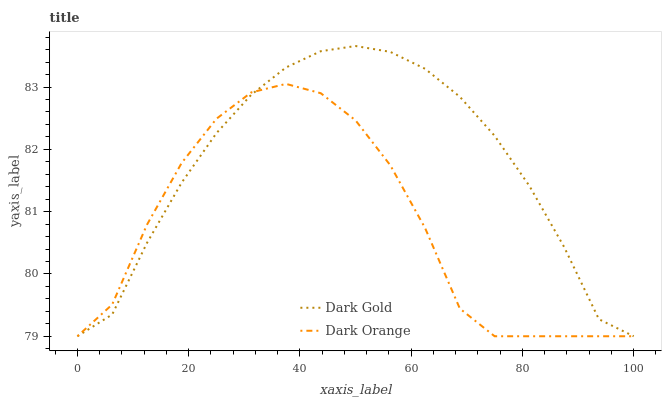Does Dark Orange have the minimum area under the curve?
Answer yes or no. Yes. Does Dark Gold have the maximum area under the curve?
Answer yes or no. Yes. Does Dark Gold have the minimum area under the curve?
Answer yes or no. No. Is Dark Gold the smoothest?
Answer yes or no. Yes. Is Dark Orange the roughest?
Answer yes or no. Yes. Is Dark Gold the roughest?
Answer yes or no. No. Does Dark Orange have the lowest value?
Answer yes or no. Yes. Does Dark Gold have the highest value?
Answer yes or no. Yes. Does Dark Orange intersect Dark Gold?
Answer yes or no. Yes. Is Dark Orange less than Dark Gold?
Answer yes or no. No. Is Dark Orange greater than Dark Gold?
Answer yes or no. No. 